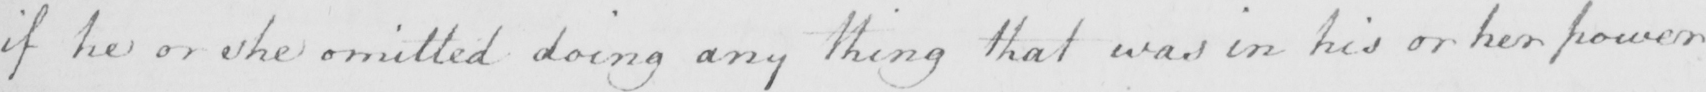Please transcribe the handwritten text in this image. if he or she omitted doing any thing that was in his or her power 